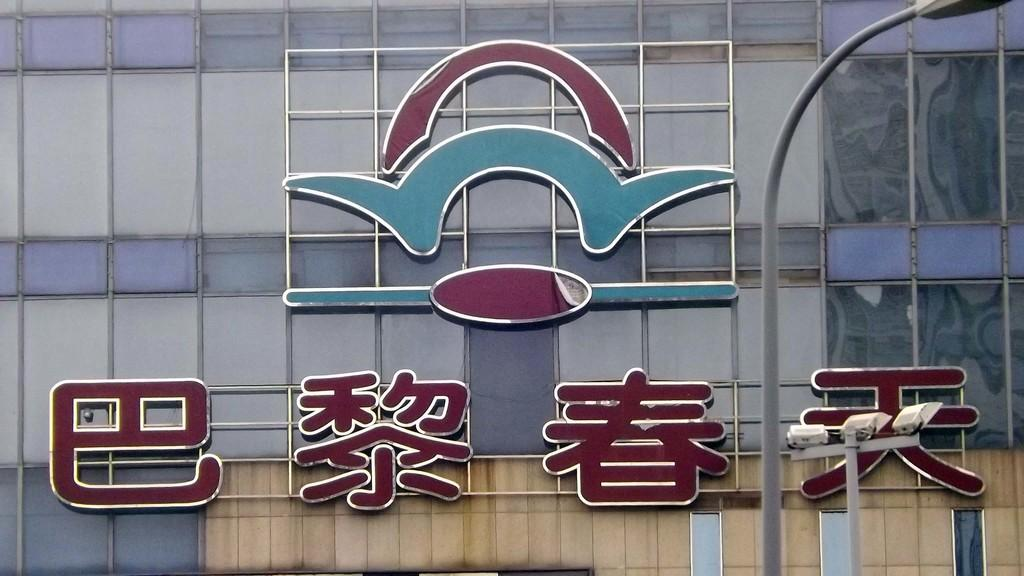What is the main feature of the image? There is a logo in the image. What else can be seen in the image besides the logo? There are letters written in a foreign language in the image. What is located on the right side of the image? There is a lamp pole on the right side of the image. How many ants can be seen crawling on the logo in the image? There are no ants present in the image. What type of structure is the son building in the image? There is no son or structure present in the image. 